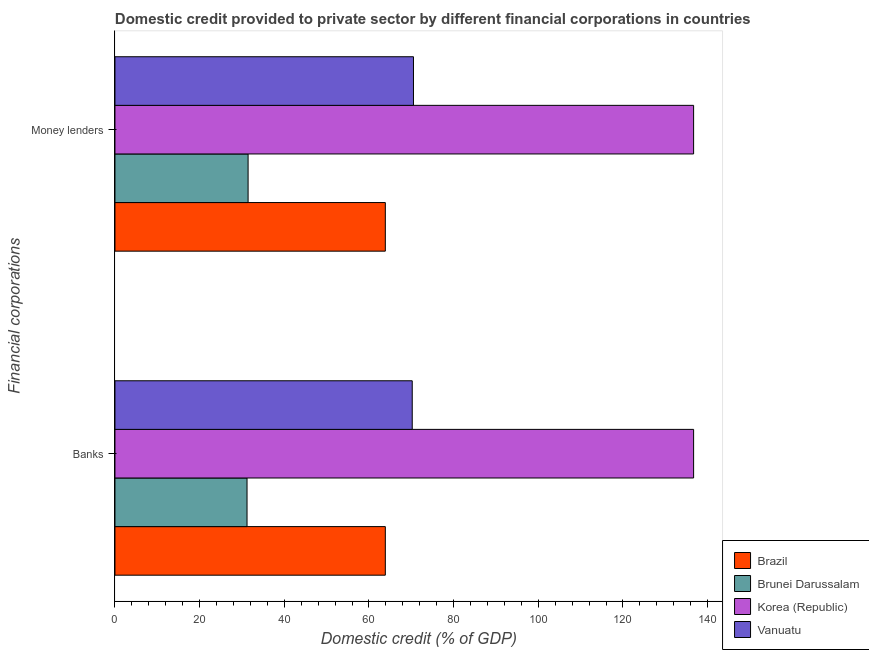How many groups of bars are there?
Make the answer very short. 2. Are the number of bars per tick equal to the number of legend labels?
Offer a very short reply. Yes. How many bars are there on the 1st tick from the bottom?
Your answer should be compact. 4. What is the label of the 2nd group of bars from the top?
Offer a very short reply. Banks. What is the domestic credit provided by money lenders in Brunei Darussalam?
Make the answer very short. 31.45. Across all countries, what is the maximum domestic credit provided by money lenders?
Give a very brief answer. 136.69. Across all countries, what is the minimum domestic credit provided by banks?
Give a very brief answer. 31.2. In which country was the domestic credit provided by banks minimum?
Keep it short and to the point. Brunei Darussalam. What is the total domestic credit provided by money lenders in the graph?
Give a very brief answer. 302.53. What is the difference between the domestic credit provided by banks in Brunei Darussalam and that in Vanuatu?
Your answer should be compact. -39.02. What is the difference between the domestic credit provided by money lenders in Brazil and the domestic credit provided by banks in Korea (Republic)?
Make the answer very short. -72.83. What is the average domestic credit provided by banks per country?
Your answer should be compact. 75.5. What is the difference between the domestic credit provided by money lenders and domestic credit provided by banks in Brunei Darussalam?
Make the answer very short. 0.25. What is the ratio of the domestic credit provided by banks in Brazil to that in Vanuatu?
Give a very brief answer. 0.91. Is the domestic credit provided by banks in Brazil less than that in Korea (Republic)?
Your answer should be compact. Yes. What does the 3rd bar from the top in Money lenders represents?
Make the answer very short. Brunei Darussalam. What does the 1st bar from the bottom in Banks represents?
Ensure brevity in your answer.  Brazil. Are all the bars in the graph horizontal?
Provide a short and direct response. Yes. How many countries are there in the graph?
Your answer should be compact. 4. Are the values on the major ticks of X-axis written in scientific E-notation?
Keep it short and to the point. No. Where does the legend appear in the graph?
Give a very brief answer. Bottom right. What is the title of the graph?
Ensure brevity in your answer.  Domestic credit provided to private sector by different financial corporations in countries. Does "Botswana" appear as one of the legend labels in the graph?
Your answer should be very brief. No. What is the label or title of the X-axis?
Ensure brevity in your answer.  Domestic credit (% of GDP). What is the label or title of the Y-axis?
Offer a terse response. Financial corporations. What is the Domestic credit (% of GDP) of Brazil in Banks?
Your response must be concise. 63.87. What is the Domestic credit (% of GDP) of Brunei Darussalam in Banks?
Your response must be concise. 31.2. What is the Domestic credit (% of GDP) in Korea (Republic) in Banks?
Make the answer very short. 136.69. What is the Domestic credit (% of GDP) of Vanuatu in Banks?
Your response must be concise. 70.22. What is the Domestic credit (% of GDP) of Brazil in Money lenders?
Offer a terse response. 63.87. What is the Domestic credit (% of GDP) in Brunei Darussalam in Money lenders?
Provide a short and direct response. 31.45. What is the Domestic credit (% of GDP) of Korea (Republic) in Money lenders?
Provide a succinct answer. 136.69. What is the Domestic credit (% of GDP) in Vanuatu in Money lenders?
Keep it short and to the point. 70.52. Across all Financial corporations, what is the maximum Domestic credit (% of GDP) in Brazil?
Your response must be concise. 63.87. Across all Financial corporations, what is the maximum Domestic credit (% of GDP) of Brunei Darussalam?
Ensure brevity in your answer.  31.45. Across all Financial corporations, what is the maximum Domestic credit (% of GDP) of Korea (Republic)?
Offer a terse response. 136.69. Across all Financial corporations, what is the maximum Domestic credit (% of GDP) of Vanuatu?
Your response must be concise. 70.52. Across all Financial corporations, what is the minimum Domestic credit (% of GDP) of Brazil?
Offer a very short reply. 63.87. Across all Financial corporations, what is the minimum Domestic credit (% of GDP) in Brunei Darussalam?
Keep it short and to the point. 31.2. Across all Financial corporations, what is the minimum Domestic credit (% of GDP) of Korea (Republic)?
Keep it short and to the point. 136.69. Across all Financial corporations, what is the minimum Domestic credit (% of GDP) in Vanuatu?
Give a very brief answer. 70.22. What is the total Domestic credit (% of GDP) of Brazil in the graph?
Provide a succinct answer. 127.74. What is the total Domestic credit (% of GDP) of Brunei Darussalam in the graph?
Make the answer very short. 62.65. What is the total Domestic credit (% of GDP) in Korea (Republic) in the graph?
Your answer should be very brief. 273.39. What is the total Domestic credit (% of GDP) in Vanuatu in the graph?
Offer a terse response. 140.74. What is the difference between the Domestic credit (% of GDP) in Brazil in Banks and that in Money lenders?
Keep it short and to the point. 0. What is the difference between the Domestic credit (% of GDP) of Brunei Darussalam in Banks and that in Money lenders?
Provide a short and direct response. -0.25. What is the difference between the Domestic credit (% of GDP) of Vanuatu in Banks and that in Money lenders?
Keep it short and to the point. -0.29. What is the difference between the Domestic credit (% of GDP) in Brazil in Banks and the Domestic credit (% of GDP) in Brunei Darussalam in Money lenders?
Give a very brief answer. 32.42. What is the difference between the Domestic credit (% of GDP) of Brazil in Banks and the Domestic credit (% of GDP) of Korea (Republic) in Money lenders?
Your answer should be compact. -72.83. What is the difference between the Domestic credit (% of GDP) of Brazil in Banks and the Domestic credit (% of GDP) of Vanuatu in Money lenders?
Offer a terse response. -6.65. What is the difference between the Domestic credit (% of GDP) in Brunei Darussalam in Banks and the Domestic credit (% of GDP) in Korea (Republic) in Money lenders?
Provide a succinct answer. -105.49. What is the difference between the Domestic credit (% of GDP) in Brunei Darussalam in Banks and the Domestic credit (% of GDP) in Vanuatu in Money lenders?
Offer a terse response. -39.31. What is the difference between the Domestic credit (% of GDP) of Korea (Republic) in Banks and the Domestic credit (% of GDP) of Vanuatu in Money lenders?
Offer a terse response. 66.18. What is the average Domestic credit (% of GDP) in Brazil per Financial corporations?
Your answer should be compact. 63.87. What is the average Domestic credit (% of GDP) in Brunei Darussalam per Financial corporations?
Keep it short and to the point. 31.33. What is the average Domestic credit (% of GDP) of Korea (Republic) per Financial corporations?
Provide a succinct answer. 136.69. What is the average Domestic credit (% of GDP) of Vanuatu per Financial corporations?
Your response must be concise. 70.37. What is the difference between the Domestic credit (% of GDP) of Brazil and Domestic credit (% of GDP) of Brunei Darussalam in Banks?
Your answer should be very brief. 32.67. What is the difference between the Domestic credit (% of GDP) in Brazil and Domestic credit (% of GDP) in Korea (Republic) in Banks?
Provide a succinct answer. -72.83. What is the difference between the Domestic credit (% of GDP) in Brazil and Domestic credit (% of GDP) in Vanuatu in Banks?
Offer a terse response. -6.36. What is the difference between the Domestic credit (% of GDP) in Brunei Darussalam and Domestic credit (% of GDP) in Korea (Republic) in Banks?
Ensure brevity in your answer.  -105.49. What is the difference between the Domestic credit (% of GDP) in Brunei Darussalam and Domestic credit (% of GDP) in Vanuatu in Banks?
Provide a succinct answer. -39.02. What is the difference between the Domestic credit (% of GDP) of Korea (Republic) and Domestic credit (% of GDP) of Vanuatu in Banks?
Your answer should be very brief. 66.47. What is the difference between the Domestic credit (% of GDP) of Brazil and Domestic credit (% of GDP) of Brunei Darussalam in Money lenders?
Your response must be concise. 32.42. What is the difference between the Domestic credit (% of GDP) in Brazil and Domestic credit (% of GDP) in Korea (Republic) in Money lenders?
Make the answer very short. -72.83. What is the difference between the Domestic credit (% of GDP) in Brazil and Domestic credit (% of GDP) in Vanuatu in Money lenders?
Provide a short and direct response. -6.65. What is the difference between the Domestic credit (% of GDP) in Brunei Darussalam and Domestic credit (% of GDP) in Korea (Republic) in Money lenders?
Provide a short and direct response. -105.24. What is the difference between the Domestic credit (% of GDP) of Brunei Darussalam and Domestic credit (% of GDP) of Vanuatu in Money lenders?
Provide a short and direct response. -39.07. What is the difference between the Domestic credit (% of GDP) of Korea (Republic) and Domestic credit (% of GDP) of Vanuatu in Money lenders?
Your answer should be very brief. 66.18. What is the ratio of the Domestic credit (% of GDP) in Brazil in Banks to that in Money lenders?
Your response must be concise. 1. What is the difference between the highest and the second highest Domestic credit (% of GDP) in Brazil?
Provide a short and direct response. 0. What is the difference between the highest and the second highest Domestic credit (% of GDP) in Brunei Darussalam?
Keep it short and to the point. 0.25. What is the difference between the highest and the second highest Domestic credit (% of GDP) of Vanuatu?
Provide a succinct answer. 0.29. What is the difference between the highest and the lowest Domestic credit (% of GDP) in Brazil?
Offer a terse response. 0. What is the difference between the highest and the lowest Domestic credit (% of GDP) in Brunei Darussalam?
Ensure brevity in your answer.  0.25. What is the difference between the highest and the lowest Domestic credit (% of GDP) of Korea (Republic)?
Give a very brief answer. 0. What is the difference between the highest and the lowest Domestic credit (% of GDP) of Vanuatu?
Offer a very short reply. 0.29. 